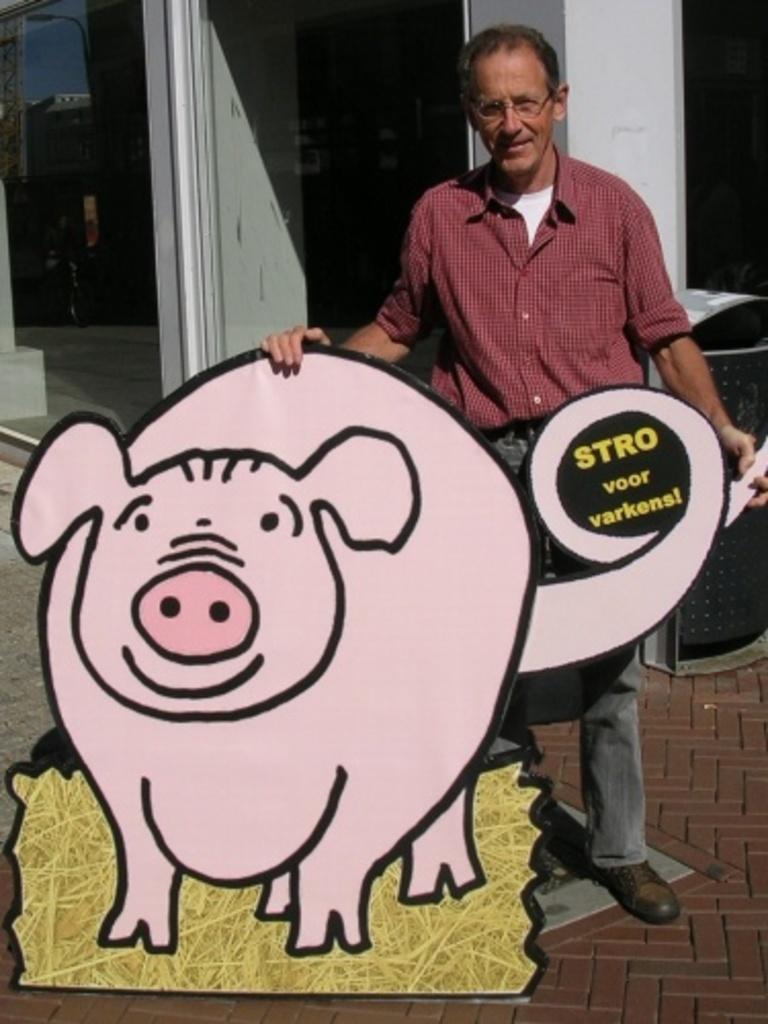In one or two sentences, can you explain what this image depicts? In this image we can see this person wearing shirt, spectacles and shoes is standing near the pig board which is placed on the floor. In the background, we can see trash can, glass windows and the wall. 